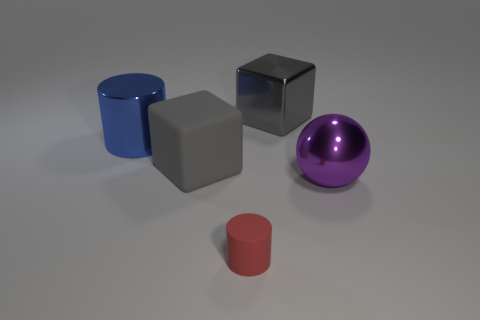Add 4 big balls. How many objects exist? 9 Subtract all cylinders. How many objects are left? 3 Add 1 big metallic cylinders. How many big metallic cylinders are left? 2 Add 1 matte cylinders. How many matte cylinders exist? 2 Subtract 1 red cylinders. How many objects are left? 4 Subtract all gray matte objects. Subtract all big yellow objects. How many objects are left? 4 